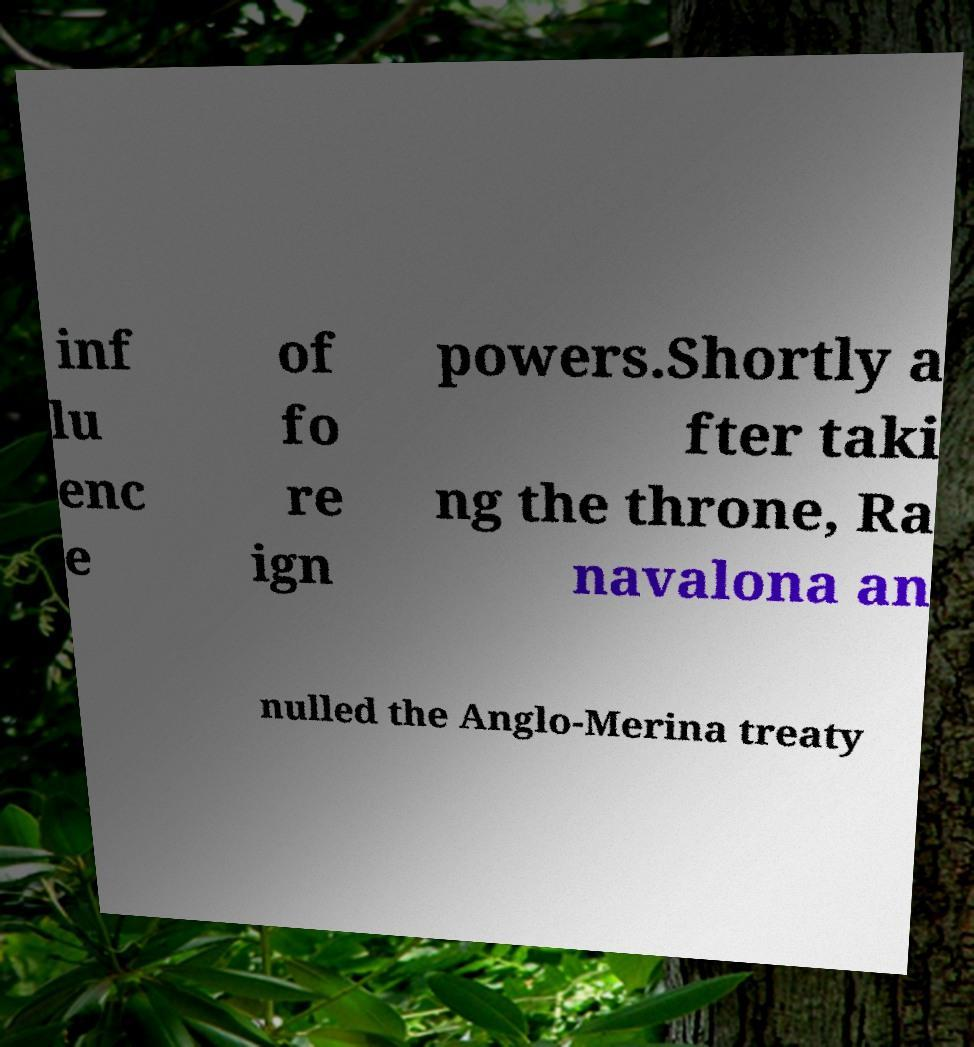Can you read and provide the text displayed in the image?This photo seems to have some interesting text. Can you extract and type it out for me? inf lu enc e of fo re ign powers.Shortly a fter taki ng the throne, Ra navalona an nulled the Anglo-Merina treaty 